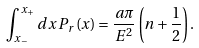Convert formula to latex. <formula><loc_0><loc_0><loc_500><loc_500>\int _ { x _ { - } } ^ { x _ { + } } d x \, P _ { r } ( x ) = { \frac { a \pi } { E ^ { 2 } } } \left ( n + \frac { 1 } { 2 } \right ) .</formula> 